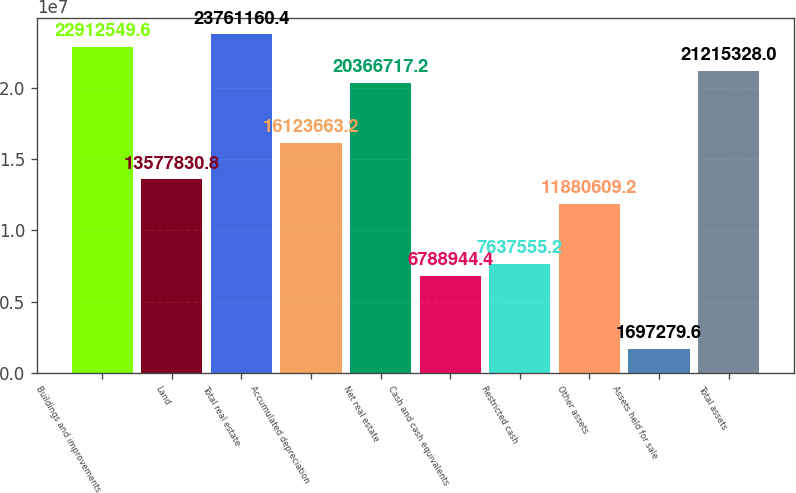<chart> <loc_0><loc_0><loc_500><loc_500><bar_chart><fcel>Buildings and improvements<fcel>Land<fcel>Total real estate<fcel>Accumulated depreciation<fcel>Net real estate<fcel>Cash and cash equivalents<fcel>Restricted cash<fcel>Other assets<fcel>Assets held for sale<fcel>Total assets<nl><fcel>2.29125e+07<fcel>1.35778e+07<fcel>2.37612e+07<fcel>1.61237e+07<fcel>2.03667e+07<fcel>6.78894e+06<fcel>7.63756e+06<fcel>1.18806e+07<fcel>1.69728e+06<fcel>2.12153e+07<nl></chart> 